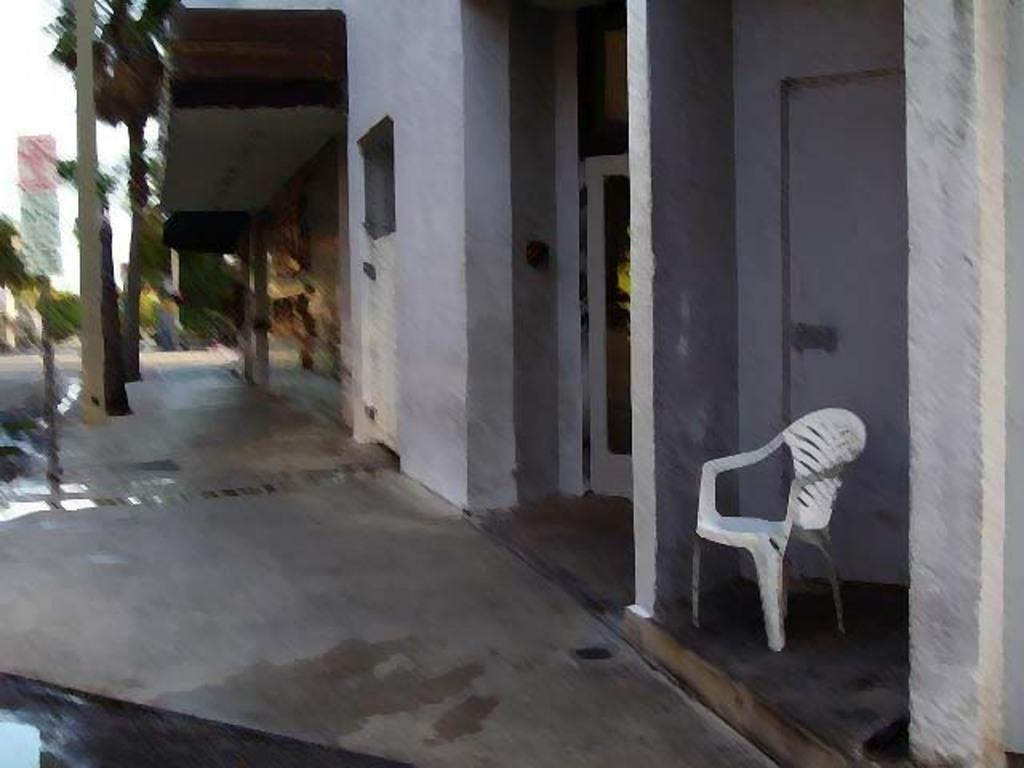What type of furniture is present in the image? There is a chair in the image. What architectural features can be seen in the image? There are pillars and buildings in the image. What additional objects are present in the image? There are boards in the image. What can be seen in the background of the image? There are trees and the sky visible in the background of the image. Can you tell me how many times the person in the image smiles? There is no person present in the image, so it is not possible to determine how many times they smile. What type of observation can be made about the quiver in the image? There is no quiver present in the image, so it is not possible to make any observations about it. 